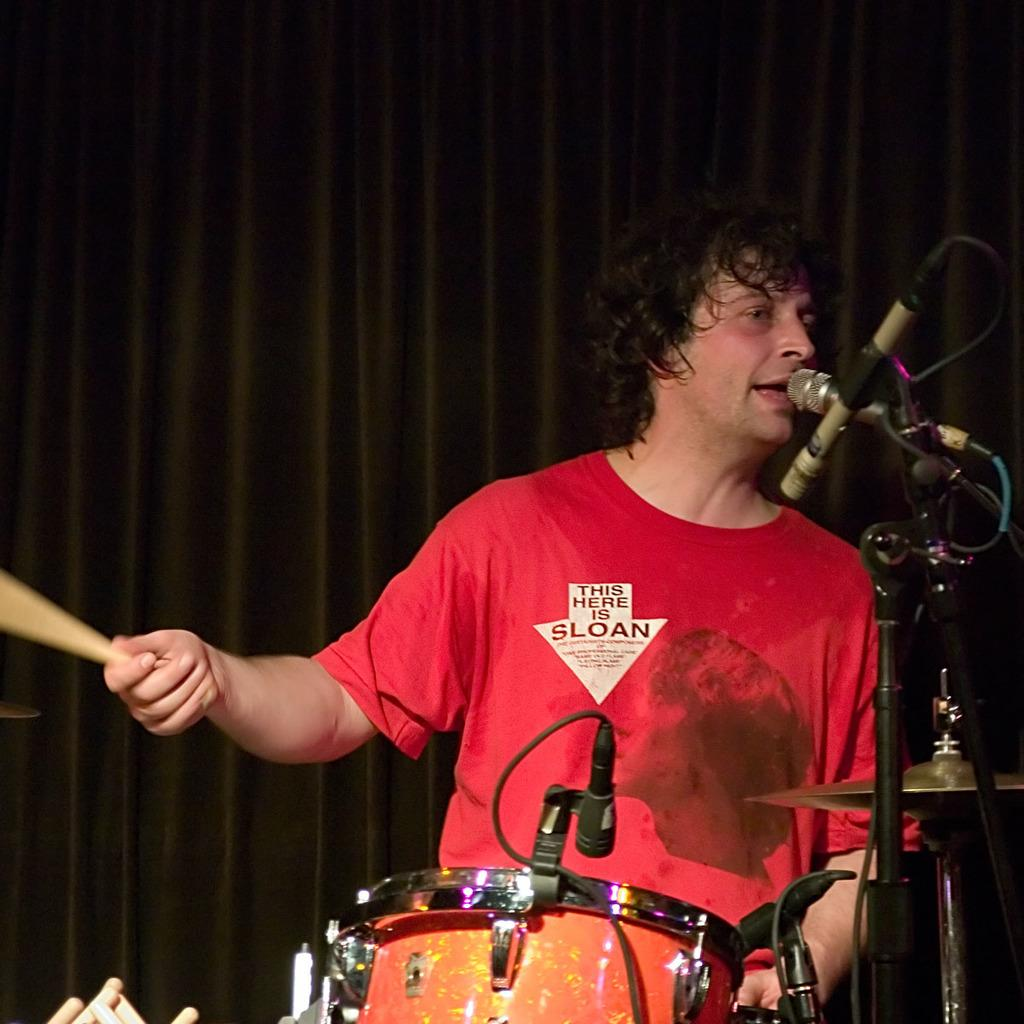What is the person in the image doing? The person is singing and playing musical instruments. What object is the person using while singing? The person is in front of a microphone. How many fish can be seen swimming in the spot where the person is folding their clothes? There are no fish or clothes-folding activity present in the image. 